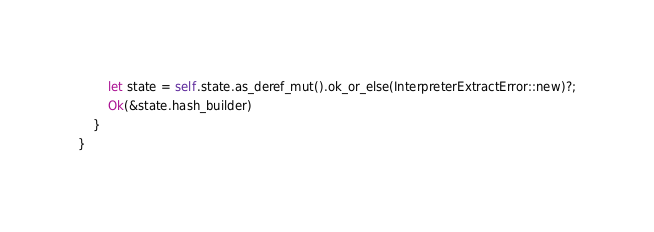Convert code to text. <code><loc_0><loc_0><loc_500><loc_500><_Rust_>        let state = self.state.as_deref_mut().ok_or_else(InterpreterExtractError::new)?;
        Ok(&state.hash_builder)
    }
}
</code> 